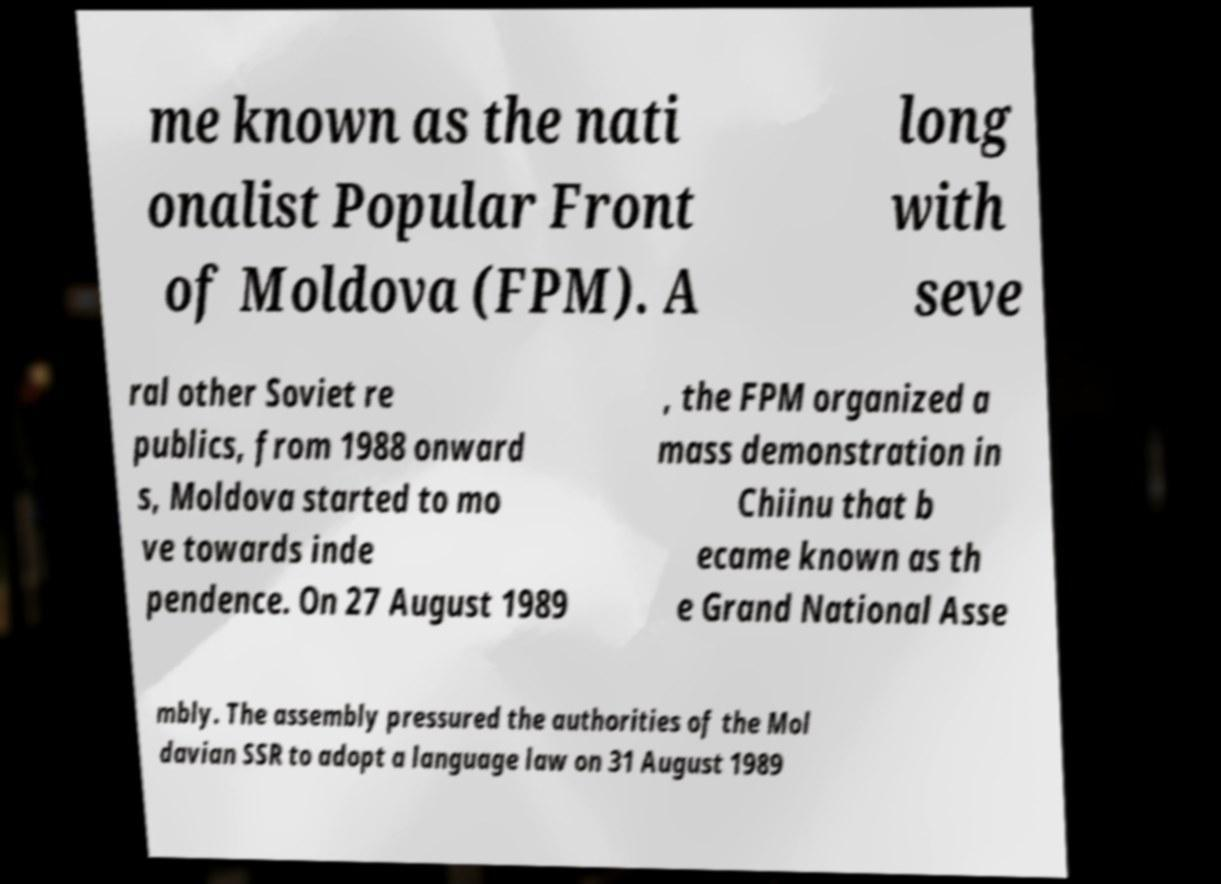Please read and relay the text visible in this image. What does it say? me known as the nati onalist Popular Front of Moldova (FPM). A long with seve ral other Soviet re publics, from 1988 onward s, Moldova started to mo ve towards inde pendence. On 27 August 1989 , the FPM organized a mass demonstration in Chiinu that b ecame known as th e Grand National Asse mbly. The assembly pressured the authorities of the Mol davian SSR to adopt a language law on 31 August 1989 